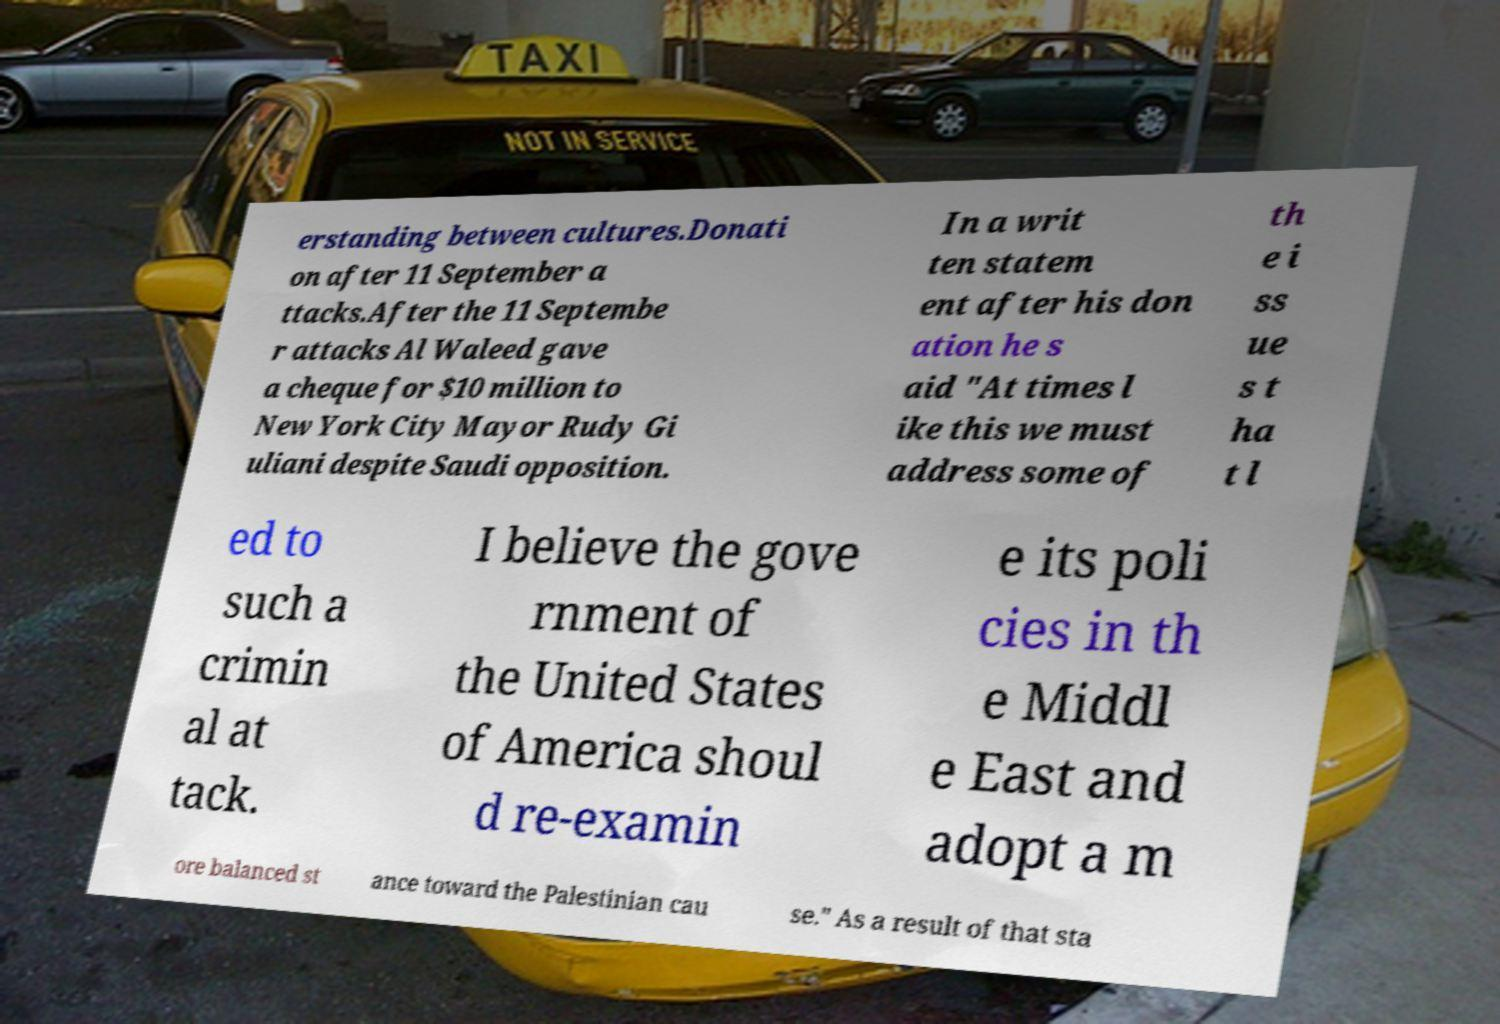Can you read and provide the text displayed in the image?This photo seems to have some interesting text. Can you extract and type it out for me? erstanding between cultures.Donati on after 11 September a ttacks.After the 11 Septembe r attacks Al Waleed gave a cheque for $10 million to New York City Mayor Rudy Gi uliani despite Saudi opposition. In a writ ten statem ent after his don ation he s aid "At times l ike this we must address some of th e i ss ue s t ha t l ed to such a crimin al at tack. I believe the gove rnment of the United States of America shoul d re-examin e its poli cies in th e Middl e East and adopt a m ore balanced st ance toward the Palestinian cau se." As a result of that sta 